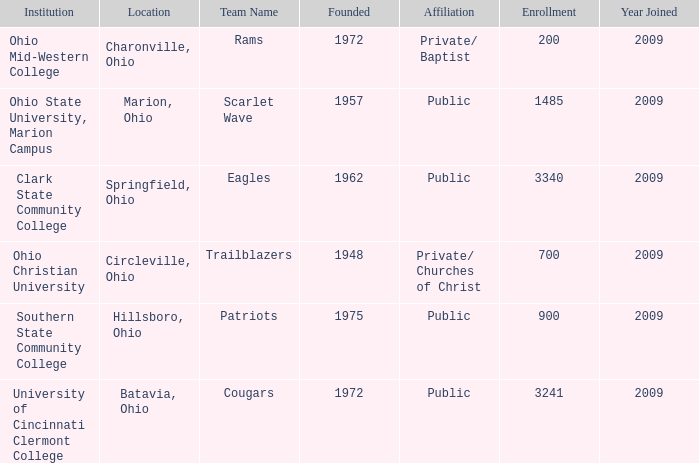What is the affiliation when the institution was ohio christian university? Private/ Churches of Christ. 